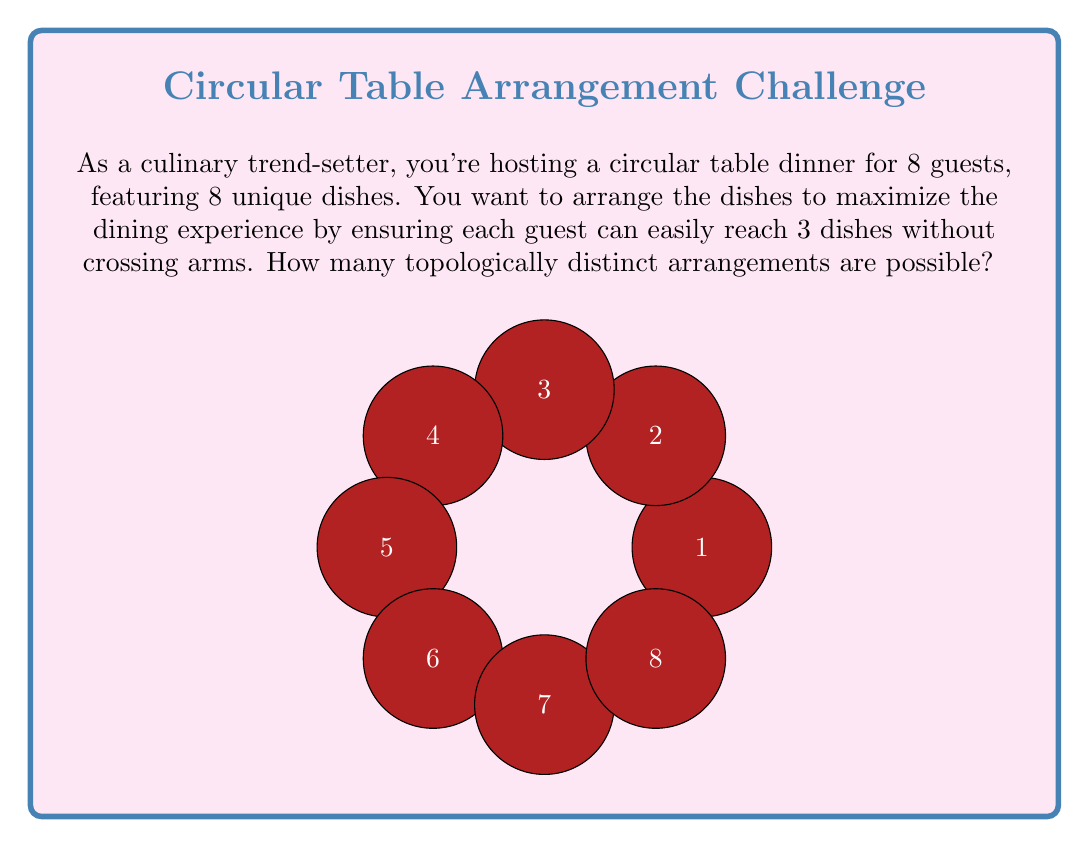Show me your answer to this math problem. Let's approach this step-by-step using concepts from topology and graph theory:

1) First, we need to understand what "topologically distinct" means in this context. Two arrangements are topologically equivalent if one can be transformed into the other by rotating the entire table or reflecting it.

2) We can represent this problem as a graph on a circle, where each point represents a dish, and edges represent the dishes each guest can reach.

3) Each guest needs to reach 3 dishes, which means each point on the circle needs to connect to 2 other points (excluding itself).

4) This forms what's known as a "chord diagram" or a "circle graph".

5) The number of topologically distinct chord diagrams with 8 points, where each point connects to 2 others, is given by the formula:

   $$\frac{1}{8} \sum_{k=1}^{7} \phi(k) \binom{8/k}{2/k}^k$$

   Where $\phi(k)$ is Euler's totient function.

6) Calculating this:
   For k = 1: $\phi(1) \binom{8}{2}^1 = 1 \cdot 28 = 28$
   For k = 2: $\phi(2) \binom{4}{1}^2 = 1 \cdot 16 = 16$
   For k = 4: $\phi(4) \binom{2}{1/2}^4 = 2 \cdot 1 = 2$
   (Other k values result in 0)

7) Sum these up: 28 + 16 + 2 = 46

8) Divide by 8: 46 / 8 = 5.75

9) Since we can only have whole arrangements, we round down to 5.
Answer: 5 distinct arrangements 